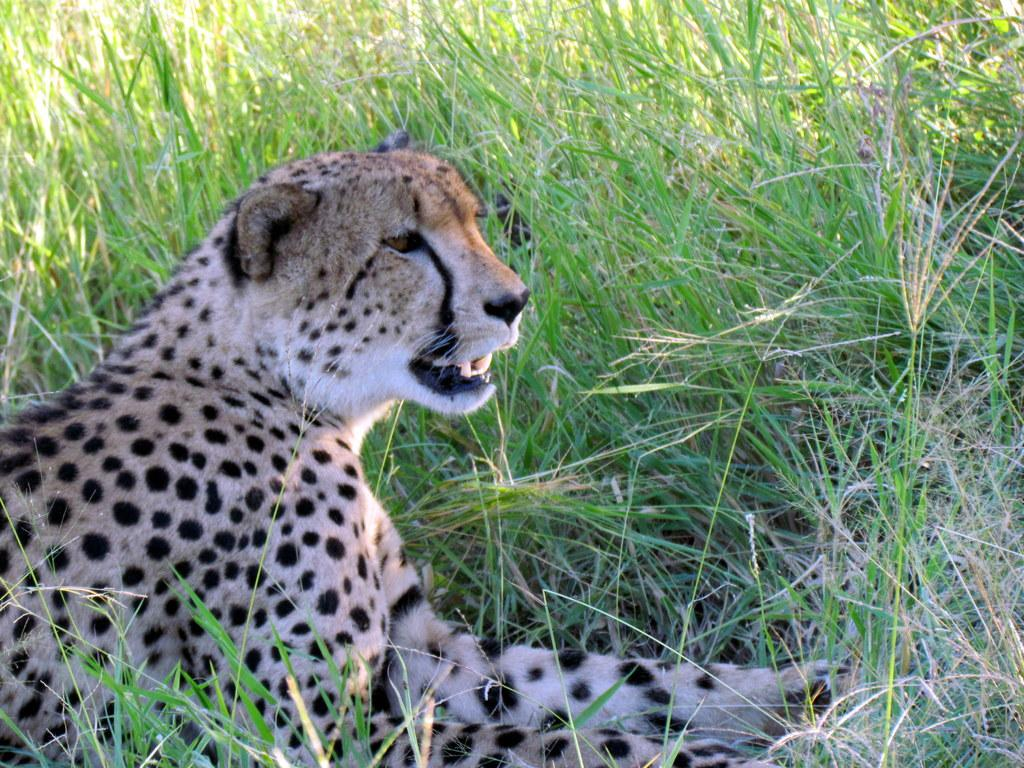What type of animal is in the image? There is a cheetah in the image. What is the background of the image? There is green grass at the bottom of the image. How many mailboxes are visible in the image? There are no mailboxes present in the image; it features a cheetah and green grass. What type of vehicles can be seen in the image? There are no vehicles present in the image. 